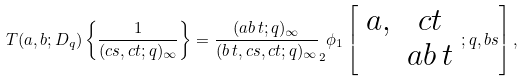Convert formula to latex. <formula><loc_0><loc_0><loc_500><loc_500>T ( a , b ; D _ { q } ) \left \{ \frac { 1 } { ( c s , c t ; q ) _ { \infty } } \right \} = \frac { ( a b \, t ; q ) _ { \infty } } { ( b \, t , c s , c t ; q ) _ { \infty } } _ { 2 } \phi _ { 1 } \left [ \begin{array} { c c } a , & c t \\ & a b \, t \end{array} ; q , b s \right ] ,</formula> 